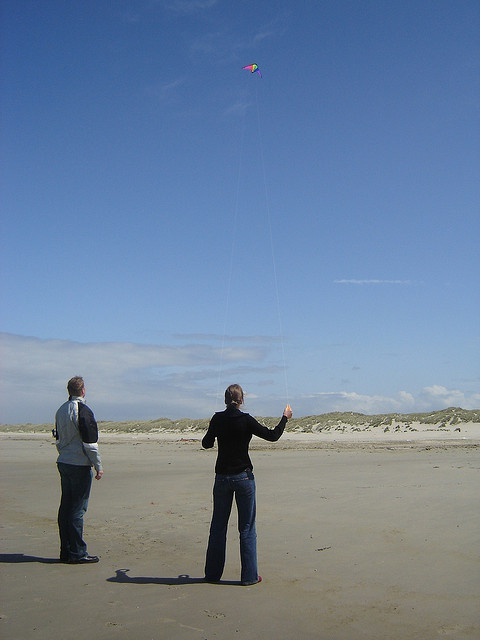Describe the objects in this image and their specific colors. I can see people in blue, black, navy, gray, and darkblue tones, people in blue, black, gray, and darkblue tones, and kite in blue, magenta, and darkblue tones in this image. 